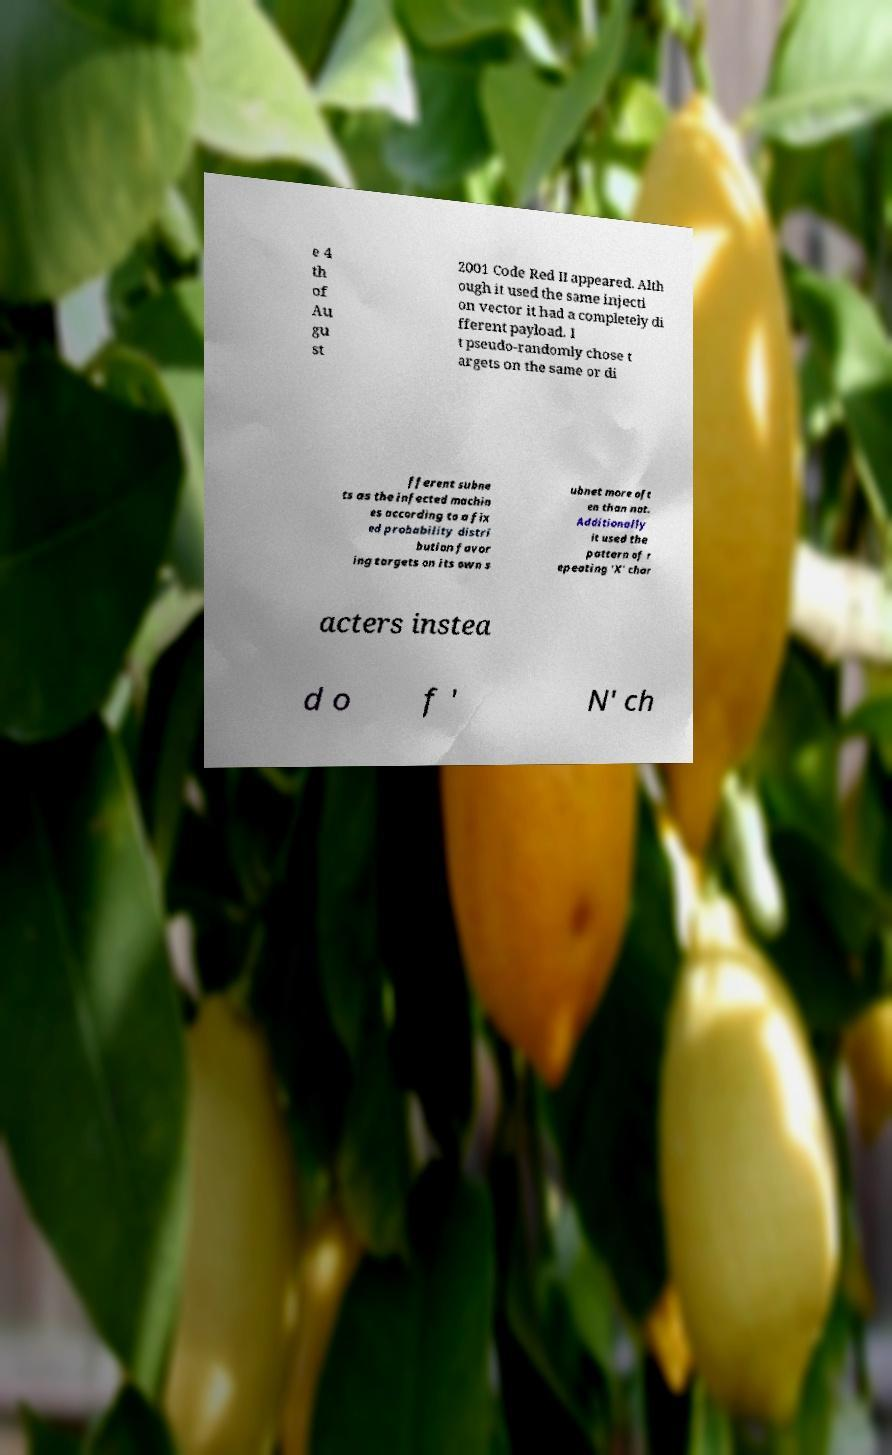Can you accurately transcribe the text from the provided image for me? e 4 th of Au gu st 2001 Code Red II appeared. Alth ough it used the same injecti on vector it had a completely di fferent payload. I t pseudo-randomly chose t argets on the same or di fferent subne ts as the infected machin es according to a fix ed probability distri bution favor ing targets on its own s ubnet more oft en than not. Additionally it used the pattern of r epeating 'X' char acters instea d o f ' N' ch 